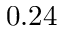Convert formula to latex. <formula><loc_0><loc_0><loc_500><loc_500>0 . 2 4</formula> 